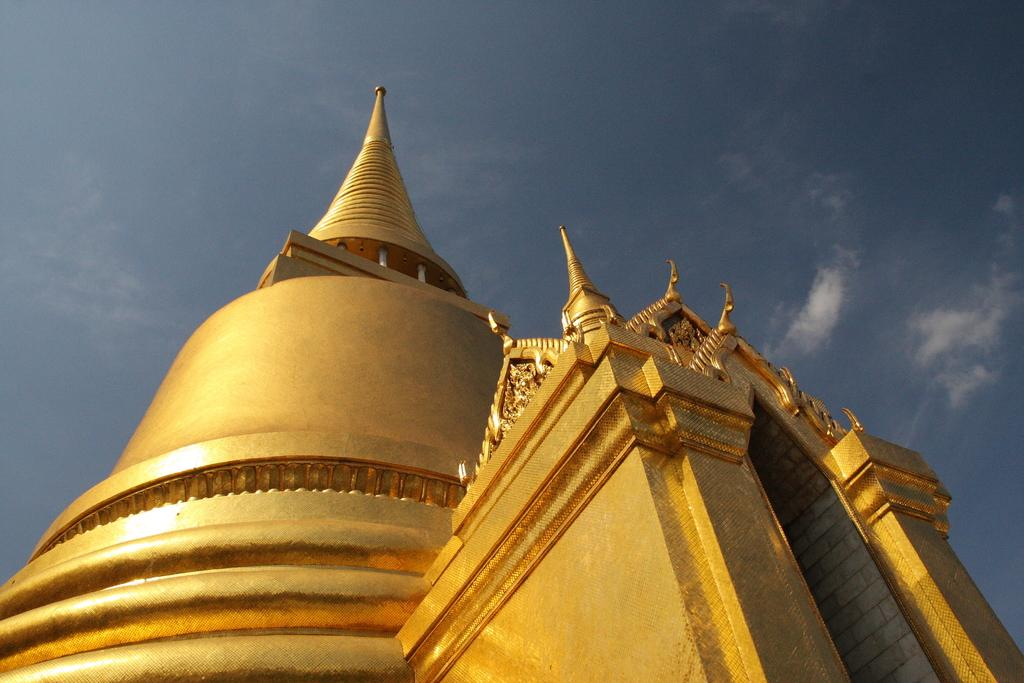What structure is located at the bottom of the image? There is a building at the bottom of the image. What is visible at the top of the image? The sky is visible at the top of the image. What can be seen in the sky in the image? Clouds are present in the sky. What type of board can be seen running across the building in the image? There is no board visible in the image, and the building is not depicted as having any boards running across it. 